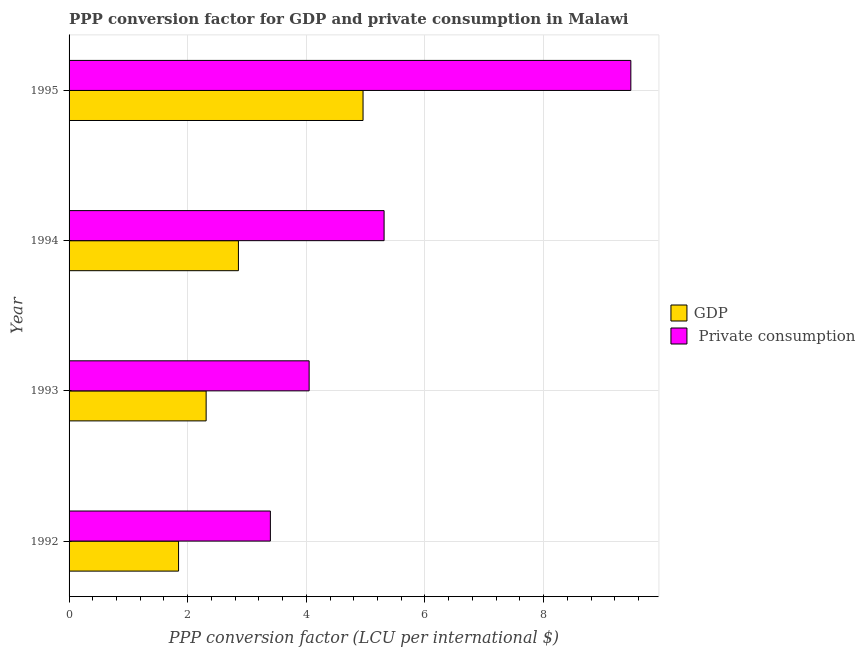How many different coloured bars are there?
Give a very brief answer. 2. Are the number of bars per tick equal to the number of legend labels?
Give a very brief answer. Yes. What is the ppp conversion factor for private consumption in 1995?
Provide a succinct answer. 9.47. Across all years, what is the maximum ppp conversion factor for private consumption?
Your answer should be very brief. 9.47. Across all years, what is the minimum ppp conversion factor for private consumption?
Provide a short and direct response. 3.39. In which year was the ppp conversion factor for private consumption minimum?
Give a very brief answer. 1992. What is the total ppp conversion factor for gdp in the graph?
Ensure brevity in your answer.  11.97. What is the difference between the ppp conversion factor for private consumption in 1994 and that in 1995?
Your answer should be compact. -4.16. What is the difference between the ppp conversion factor for gdp in 1995 and the ppp conversion factor for private consumption in 1994?
Offer a terse response. -0.35. What is the average ppp conversion factor for gdp per year?
Give a very brief answer. 2.99. In the year 1994, what is the difference between the ppp conversion factor for private consumption and ppp conversion factor for gdp?
Offer a very short reply. 2.46. What is the ratio of the ppp conversion factor for private consumption in 1992 to that in 1994?
Give a very brief answer. 0.64. Is the ppp conversion factor for gdp in 1992 less than that in 1995?
Your response must be concise. Yes. Is the difference between the ppp conversion factor for gdp in 1993 and 1995 greater than the difference between the ppp conversion factor for private consumption in 1993 and 1995?
Make the answer very short. Yes. What is the difference between the highest and the second highest ppp conversion factor for private consumption?
Keep it short and to the point. 4.16. What is the difference between the highest and the lowest ppp conversion factor for gdp?
Make the answer very short. 3.11. In how many years, is the ppp conversion factor for private consumption greater than the average ppp conversion factor for private consumption taken over all years?
Your answer should be compact. 1. Is the sum of the ppp conversion factor for private consumption in 1992 and 1995 greater than the maximum ppp conversion factor for gdp across all years?
Offer a terse response. Yes. What does the 1st bar from the top in 1992 represents?
Give a very brief answer.  Private consumption. What does the 1st bar from the bottom in 1994 represents?
Provide a short and direct response. GDP. How many bars are there?
Your answer should be very brief. 8. Are all the bars in the graph horizontal?
Keep it short and to the point. Yes. How many years are there in the graph?
Give a very brief answer. 4. What is the difference between two consecutive major ticks on the X-axis?
Provide a short and direct response. 2. Are the values on the major ticks of X-axis written in scientific E-notation?
Provide a short and direct response. No. Does the graph contain any zero values?
Provide a succinct answer. No. Does the graph contain grids?
Provide a short and direct response. Yes. Where does the legend appear in the graph?
Offer a terse response. Center right. What is the title of the graph?
Keep it short and to the point. PPP conversion factor for GDP and private consumption in Malawi. Does "Travel services" appear as one of the legend labels in the graph?
Ensure brevity in your answer.  No. What is the label or title of the X-axis?
Ensure brevity in your answer.  PPP conversion factor (LCU per international $). What is the PPP conversion factor (LCU per international $) of GDP in 1992?
Ensure brevity in your answer.  1.85. What is the PPP conversion factor (LCU per international $) in  Private consumption in 1992?
Keep it short and to the point. 3.39. What is the PPP conversion factor (LCU per international $) of GDP in 1993?
Offer a very short reply. 2.31. What is the PPP conversion factor (LCU per international $) of  Private consumption in 1993?
Offer a very short reply. 4.05. What is the PPP conversion factor (LCU per international $) in GDP in 1994?
Keep it short and to the point. 2.85. What is the PPP conversion factor (LCU per international $) of  Private consumption in 1994?
Make the answer very short. 5.31. What is the PPP conversion factor (LCU per international $) of GDP in 1995?
Keep it short and to the point. 4.96. What is the PPP conversion factor (LCU per international $) of  Private consumption in 1995?
Make the answer very short. 9.47. Across all years, what is the maximum PPP conversion factor (LCU per international $) in GDP?
Make the answer very short. 4.96. Across all years, what is the maximum PPP conversion factor (LCU per international $) in  Private consumption?
Your response must be concise. 9.47. Across all years, what is the minimum PPP conversion factor (LCU per international $) in GDP?
Provide a succinct answer. 1.85. Across all years, what is the minimum PPP conversion factor (LCU per international $) in  Private consumption?
Your answer should be compact. 3.39. What is the total PPP conversion factor (LCU per international $) of GDP in the graph?
Provide a succinct answer. 11.97. What is the total PPP conversion factor (LCU per international $) of  Private consumption in the graph?
Make the answer very short. 22.22. What is the difference between the PPP conversion factor (LCU per international $) of GDP in 1992 and that in 1993?
Provide a succinct answer. -0.47. What is the difference between the PPP conversion factor (LCU per international $) in  Private consumption in 1992 and that in 1993?
Give a very brief answer. -0.65. What is the difference between the PPP conversion factor (LCU per international $) of GDP in 1992 and that in 1994?
Give a very brief answer. -1.01. What is the difference between the PPP conversion factor (LCU per international $) in  Private consumption in 1992 and that in 1994?
Offer a very short reply. -1.92. What is the difference between the PPP conversion factor (LCU per international $) in GDP in 1992 and that in 1995?
Provide a succinct answer. -3.11. What is the difference between the PPP conversion factor (LCU per international $) of  Private consumption in 1992 and that in 1995?
Make the answer very short. -6.08. What is the difference between the PPP conversion factor (LCU per international $) in GDP in 1993 and that in 1994?
Provide a short and direct response. -0.54. What is the difference between the PPP conversion factor (LCU per international $) of  Private consumption in 1993 and that in 1994?
Provide a short and direct response. -1.26. What is the difference between the PPP conversion factor (LCU per international $) of GDP in 1993 and that in 1995?
Make the answer very short. -2.65. What is the difference between the PPP conversion factor (LCU per international $) in  Private consumption in 1993 and that in 1995?
Give a very brief answer. -5.42. What is the difference between the PPP conversion factor (LCU per international $) in GDP in 1994 and that in 1995?
Your answer should be compact. -2.1. What is the difference between the PPP conversion factor (LCU per international $) of  Private consumption in 1994 and that in 1995?
Give a very brief answer. -4.16. What is the difference between the PPP conversion factor (LCU per international $) of GDP in 1992 and the PPP conversion factor (LCU per international $) of  Private consumption in 1993?
Offer a terse response. -2.2. What is the difference between the PPP conversion factor (LCU per international $) of GDP in 1992 and the PPP conversion factor (LCU per international $) of  Private consumption in 1994?
Ensure brevity in your answer.  -3.46. What is the difference between the PPP conversion factor (LCU per international $) in GDP in 1992 and the PPP conversion factor (LCU per international $) in  Private consumption in 1995?
Your answer should be very brief. -7.62. What is the difference between the PPP conversion factor (LCU per international $) of GDP in 1993 and the PPP conversion factor (LCU per international $) of  Private consumption in 1994?
Ensure brevity in your answer.  -3. What is the difference between the PPP conversion factor (LCU per international $) of GDP in 1993 and the PPP conversion factor (LCU per international $) of  Private consumption in 1995?
Provide a short and direct response. -7.16. What is the difference between the PPP conversion factor (LCU per international $) of GDP in 1994 and the PPP conversion factor (LCU per international $) of  Private consumption in 1995?
Your answer should be very brief. -6.62. What is the average PPP conversion factor (LCU per international $) in GDP per year?
Make the answer very short. 2.99. What is the average PPP conversion factor (LCU per international $) in  Private consumption per year?
Keep it short and to the point. 5.56. In the year 1992, what is the difference between the PPP conversion factor (LCU per international $) of GDP and PPP conversion factor (LCU per international $) of  Private consumption?
Your answer should be very brief. -1.55. In the year 1993, what is the difference between the PPP conversion factor (LCU per international $) in GDP and PPP conversion factor (LCU per international $) in  Private consumption?
Your answer should be very brief. -1.74. In the year 1994, what is the difference between the PPP conversion factor (LCU per international $) of GDP and PPP conversion factor (LCU per international $) of  Private consumption?
Offer a very short reply. -2.46. In the year 1995, what is the difference between the PPP conversion factor (LCU per international $) of GDP and PPP conversion factor (LCU per international $) of  Private consumption?
Provide a succinct answer. -4.51. What is the ratio of the PPP conversion factor (LCU per international $) of GDP in 1992 to that in 1993?
Ensure brevity in your answer.  0.8. What is the ratio of the PPP conversion factor (LCU per international $) in  Private consumption in 1992 to that in 1993?
Make the answer very short. 0.84. What is the ratio of the PPP conversion factor (LCU per international $) in GDP in 1992 to that in 1994?
Your response must be concise. 0.65. What is the ratio of the PPP conversion factor (LCU per international $) in  Private consumption in 1992 to that in 1994?
Keep it short and to the point. 0.64. What is the ratio of the PPP conversion factor (LCU per international $) of GDP in 1992 to that in 1995?
Your answer should be compact. 0.37. What is the ratio of the PPP conversion factor (LCU per international $) of  Private consumption in 1992 to that in 1995?
Your answer should be very brief. 0.36. What is the ratio of the PPP conversion factor (LCU per international $) of GDP in 1993 to that in 1994?
Give a very brief answer. 0.81. What is the ratio of the PPP conversion factor (LCU per international $) of  Private consumption in 1993 to that in 1994?
Provide a short and direct response. 0.76. What is the ratio of the PPP conversion factor (LCU per international $) of GDP in 1993 to that in 1995?
Ensure brevity in your answer.  0.47. What is the ratio of the PPP conversion factor (LCU per international $) in  Private consumption in 1993 to that in 1995?
Offer a terse response. 0.43. What is the ratio of the PPP conversion factor (LCU per international $) in GDP in 1994 to that in 1995?
Your answer should be compact. 0.58. What is the ratio of the PPP conversion factor (LCU per international $) in  Private consumption in 1994 to that in 1995?
Offer a terse response. 0.56. What is the difference between the highest and the second highest PPP conversion factor (LCU per international $) of GDP?
Your response must be concise. 2.1. What is the difference between the highest and the second highest PPP conversion factor (LCU per international $) of  Private consumption?
Provide a short and direct response. 4.16. What is the difference between the highest and the lowest PPP conversion factor (LCU per international $) of GDP?
Keep it short and to the point. 3.11. What is the difference between the highest and the lowest PPP conversion factor (LCU per international $) of  Private consumption?
Your response must be concise. 6.08. 